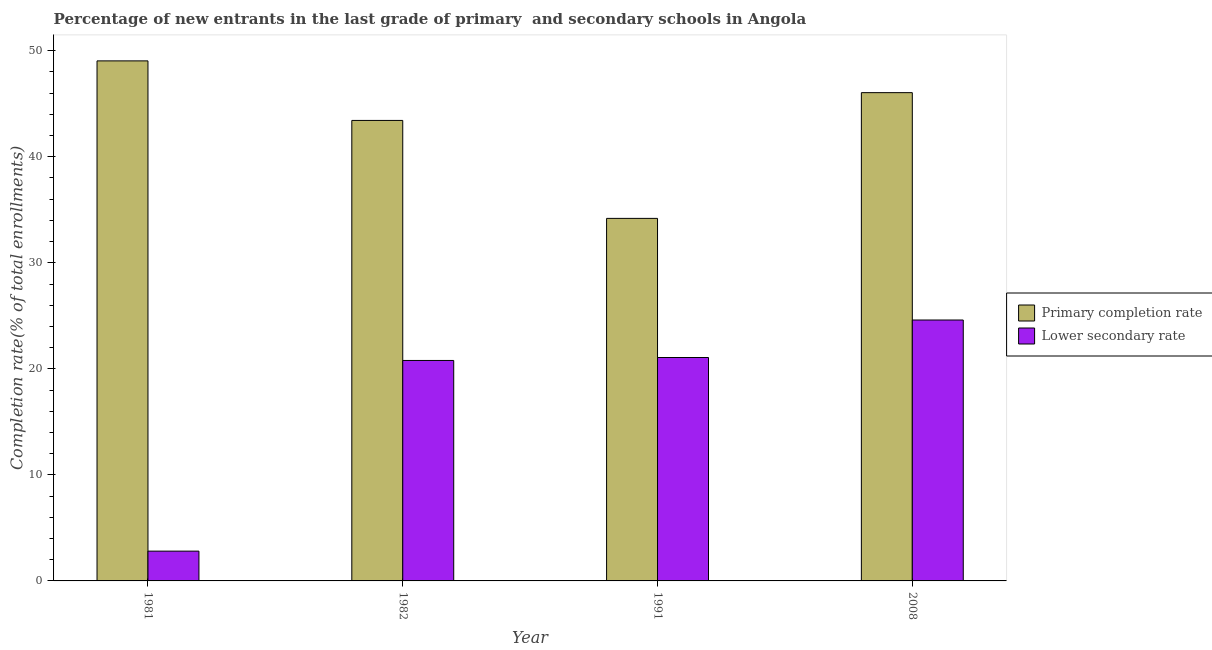Are the number of bars per tick equal to the number of legend labels?
Give a very brief answer. Yes. How many bars are there on the 2nd tick from the left?
Your answer should be very brief. 2. How many bars are there on the 2nd tick from the right?
Give a very brief answer. 2. In how many cases, is the number of bars for a given year not equal to the number of legend labels?
Your answer should be very brief. 0. What is the completion rate in primary schools in 1981?
Offer a terse response. 49.04. Across all years, what is the maximum completion rate in primary schools?
Give a very brief answer. 49.04. Across all years, what is the minimum completion rate in primary schools?
Give a very brief answer. 34.19. What is the total completion rate in secondary schools in the graph?
Ensure brevity in your answer.  69.28. What is the difference between the completion rate in primary schools in 1981 and that in 1982?
Provide a short and direct response. 5.62. What is the difference between the completion rate in secondary schools in 1991 and the completion rate in primary schools in 1982?
Ensure brevity in your answer.  0.28. What is the average completion rate in primary schools per year?
Make the answer very short. 43.18. In how many years, is the completion rate in primary schools greater than 32 %?
Your answer should be very brief. 4. What is the ratio of the completion rate in secondary schools in 1991 to that in 2008?
Your response must be concise. 0.86. What is the difference between the highest and the second highest completion rate in primary schools?
Offer a terse response. 3. What is the difference between the highest and the lowest completion rate in secondary schools?
Offer a terse response. 21.8. What does the 1st bar from the left in 1991 represents?
Your answer should be very brief. Primary completion rate. What does the 1st bar from the right in 1981 represents?
Your answer should be compact. Lower secondary rate. Does the graph contain any zero values?
Your response must be concise. No. What is the title of the graph?
Your response must be concise. Percentage of new entrants in the last grade of primary  and secondary schools in Angola. What is the label or title of the Y-axis?
Give a very brief answer. Completion rate(% of total enrollments). What is the Completion rate(% of total enrollments) in Primary completion rate in 1981?
Your answer should be very brief. 49.04. What is the Completion rate(% of total enrollments) in Lower secondary rate in 1981?
Give a very brief answer. 2.81. What is the Completion rate(% of total enrollments) in Primary completion rate in 1982?
Make the answer very short. 43.43. What is the Completion rate(% of total enrollments) of Lower secondary rate in 1982?
Your answer should be compact. 20.79. What is the Completion rate(% of total enrollments) in Primary completion rate in 1991?
Provide a succinct answer. 34.19. What is the Completion rate(% of total enrollments) of Lower secondary rate in 1991?
Ensure brevity in your answer.  21.07. What is the Completion rate(% of total enrollments) in Primary completion rate in 2008?
Your response must be concise. 46.05. What is the Completion rate(% of total enrollments) of Lower secondary rate in 2008?
Give a very brief answer. 24.61. Across all years, what is the maximum Completion rate(% of total enrollments) of Primary completion rate?
Ensure brevity in your answer.  49.04. Across all years, what is the maximum Completion rate(% of total enrollments) in Lower secondary rate?
Your answer should be compact. 24.61. Across all years, what is the minimum Completion rate(% of total enrollments) of Primary completion rate?
Your response must be concise. 34.19. Across all years, what is the minimum Completion rate(% of total enrollments) in Lower secondary rate?
Give a very brief answer. 2.81. What is the total Completion rate(% of total enrollments) in Primary completion rate in the graph?
Your response must be concise. 172.71. What is the total Completion rate(% of total enrollments) in Lower secondary rate in the graph?
Provide a short and direct response. 69.28. What is the difference between the Completion rate(% of total enrollments) of Primary completion rate in 1981 and that in 1982?
Ensure brevity in your answer.  5.62. What is the difference between the Completion rate(% of total enrollments) in Lower secondary rate in 1981 and that in 1982?
Your answer should be very brief. -17.98. What is the difference between the Completion rate(% of total enrollments) in Primary completion rate in 1981 and that in 1991?
Your answer should be very brief. 14.85. What is the difference between the Completion rate(% of total enrollments) of Lower secondary rate in 1981 and that in 1991?
Ensure brevity in your answer.  -18.26. What is the difference between the Completion rate(% of total enrollments) of Primary completion rate in 1981 and that in 2008?
Ensure brevity in your answer.  3. What is the difference between the Completion rate(% of total enrollments) of Lower secondary rate in 1981 and that in 2008?
Keep it short and to the point. -21.8. What is the difference between the Completion rate(% of total enrollments) of Primary completion rate in 1982 and that in 1991?
Keep it short and to the point. 9.24. What is the difference between the Completion rate(% of total enrollments) of Lower secondary rate in 1982 and that in 1991?
Provide a short and direct response. -0.28. What is the difference between the Completion rate(% of total enrollments) in Primary completion rate in 1982 and that in 2008?
Ensure brevity in your answer.  -2.62. What is the difference between the Completion rate(% of total enrollments) in Lower secondary rate in 1982 and that in 2008?
Give a very brief answer. -3.81. What is the difference between the Completion rate(% of total enrollments) in Primary completion rate in 1991 and that in 2008?
Keep it short and to the point. -11.86. What is the difference between the Completion rate(% of total enrollments) in Lower secondary rate in 1991 and that in 2008?
Provide a succinct answer. -3.54. What is the difference between the Completion rate(% of total enrollments) in Primary completion rate in 1981 and the Completion rate(% of total enrollments) in Lower secondary rate in 1982?
Your answer should be very brief. 28.25. What is the difference between the Completion rate(% of total enrollments) of Primary completion rate in 1981 and the Completion rate(% of total enrollments) of Lower secondary rate in 1991?
Make the answer very short. 27.97. What is the difference between the Completion rate(% of total enrollments) of Primary completion rate in 1981 and the Completion rate(% of total enrollments) of Lower secondary rate in 2008?
Your response must be concise. 24.44. What is the difference between the Completion rate(% of total enrollments) in Primary completion rate in 1982 and the Completion rate(% of total enrollments) in Lower secondary rate in 1991?
Keep it short and to the point. 22.36. What is the difference between the Completion rate(% of total enrollments) of Primary completion rate in 1982 and the Completion rate(% of total enrollments) of Lower secondary rate in 2008?
Keep it short and to the point. 18.82. What is the difference between the Completion rate(% of total enrollments) in Primary completion rate in 1991 and the Completion rate(% of total enrollments) in Lower secondary rate in 2008?
Your response must be concise. 9.58. What is the average Completion rate(% of total enrollments) of Primary completion rate per year?
Keep it short and to the point. 43.18. What is the average Completion rate(% of total enrollments) in Lower secondary rate per year?
Give a very brief answer. 17.32. In the year 1981, what is the difference between the Completion rate(% of total enrollments) in Primary completion rate and Completion rate(% of total enrollments) in Lower secondary rate?
Your answer should be compact. 46.23. In the year 1982, what is the difference between the Completion rate(% of total enrollments) in Primary completion rate and Completion rate(% of total enrollments) in Lower secondary rate?
Your answer should be very brief. 22.64. In the year 1991, what is the difference between the Completion rate(% of total enrollments) of Primary completion rate and Completion rate(% of total enrollments) of Lower secondary rate?
Keep it short and to the point. 13.12. In the year 2008, what is the difference between the Completion rate(% of total enrollments) in Primary completion rate and Completion rate(% of total enrollments) in Lower secondary rate?
Your answer should be compact. 21.44. What is the ratio of the Completion rate(% of total enrollments) of Primary completion rate in 1981 to that in 1982?
Keep it short and to the point. 1.13. What is the ratio of the Completion rate(% of total enrollments) of Lower secondary rate in 1981 to that in 1982?
Provide a succinct answer. 0.14. What is the ratio of the Completion rate(% of total enrollments) in Primary completion rate in 1981 to that in 1991?
Your answer should be very brief. 1.43. What is the ratio of the Completion rate(% of total enrollments) in Lower secondary rate in 1981 to that in 1991?
Keep it short and to the point. 0.13. What is the ratio of the Completion rate(% of total enrollments) in Primary completion rate in 1981 to that in 2008?
Offer a terse response. 1.07. What is the ratio of the Completion rate(% of total enrollments) in Lower secondary rate in 1981 to that in 2008?
Ensure brevity in your answer.  0.11. What is the ratio of the Completion rate(% of total enrollments) in Primary completion rate in 1982 to that in 1991?
Your answer should be compact. 1.27. What is the ratio of the Completion rate(% of total enrollments) in Lower secondary rate in 1982 to that in 1991?
Your answer should be compact. 0.99. What is the ratio of the Completion rate(% of total enrollments) in Primary completion rate in 1982 to that in 2008?
Offer a terse response. 0.94. What is the ratio of the Completion rate(% of total enrollments) in Lower secondary rate in 1982 to that in 2008?
Your response must be concise. 0.84. What is the ratio of the Completion rate(% of total enrollments) of Primary completion rate in 1991 to that in 2008?
Your answer should be compact. 0.74. What is the ratio of the Completion rate(% of total enrollments) in Lower secondary rate in 1991 to that in 2008?
Ensure brevity in your answer.  0.86. What is the difference between the highest and the second highest Completion rate(% of total enrollments) in Primary completion rate?
Provide a short and direct response. 3. What is the difference between the highest and the second highest Completion rate(% of total enrollments) of Lower secondary rate?
Your answer should be compact. 3.54. What is the difference between the highest and the lowest Completion rate(% of total enrollments) in Primary completion rate?
Keep it short and to the point. 14.85. What is the difference between the highest and the lowest Completion rate(% of total enrollments) of Lower secondary rate?
Offer a very short reply. 21.8. 